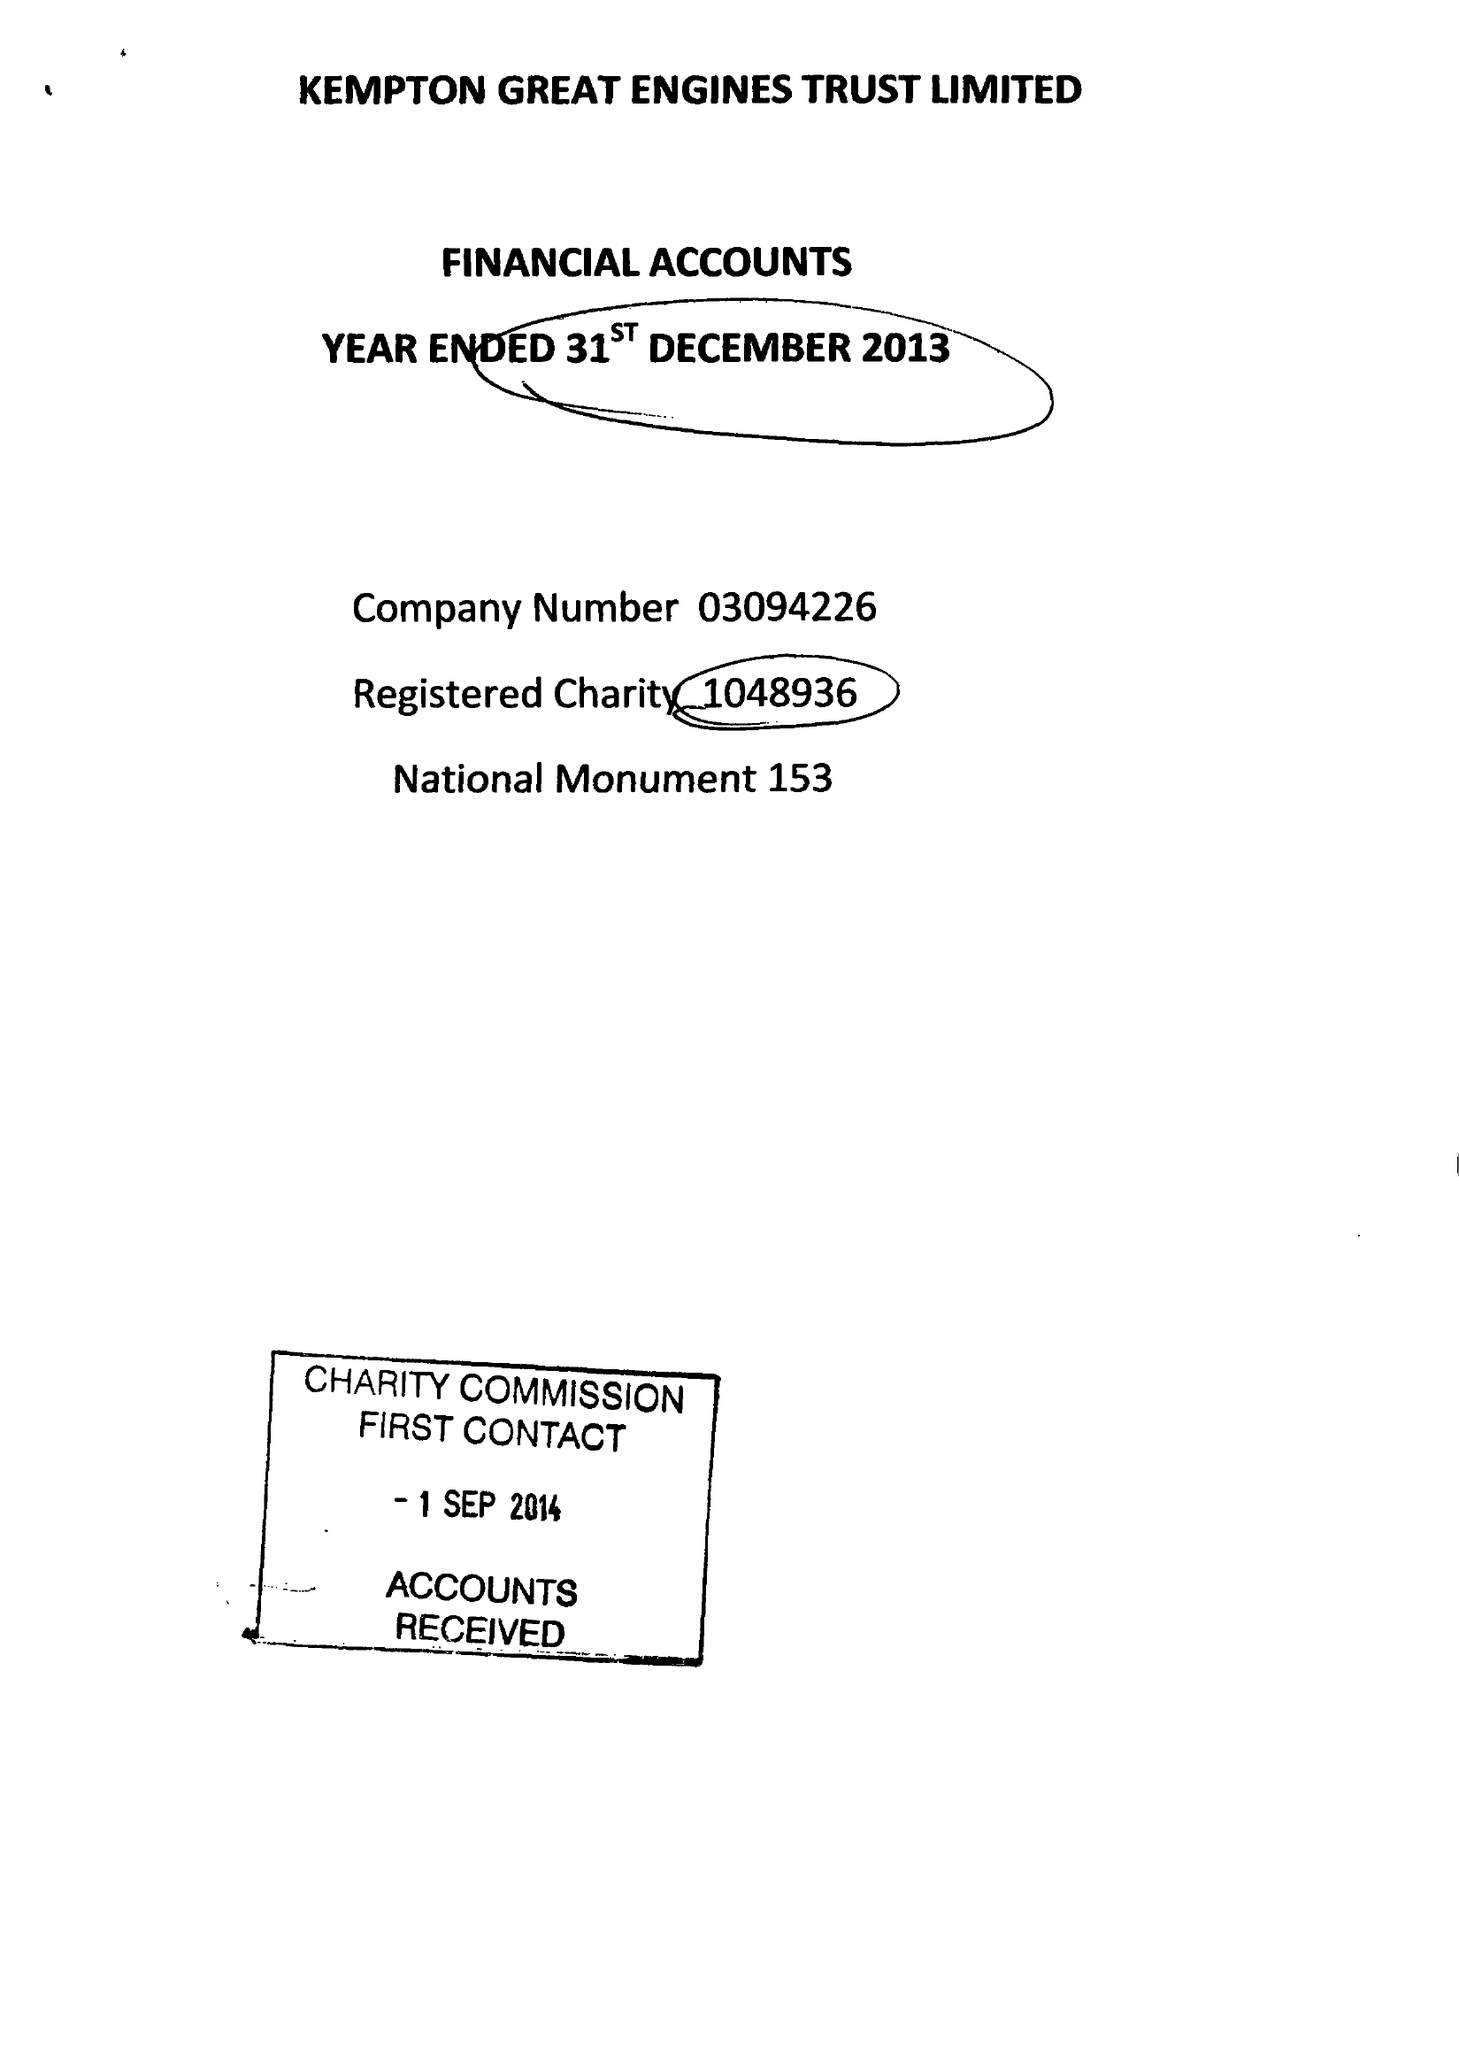What is the value for the report_date?
Answer the question using a single word or phrase. 2013-12-31 